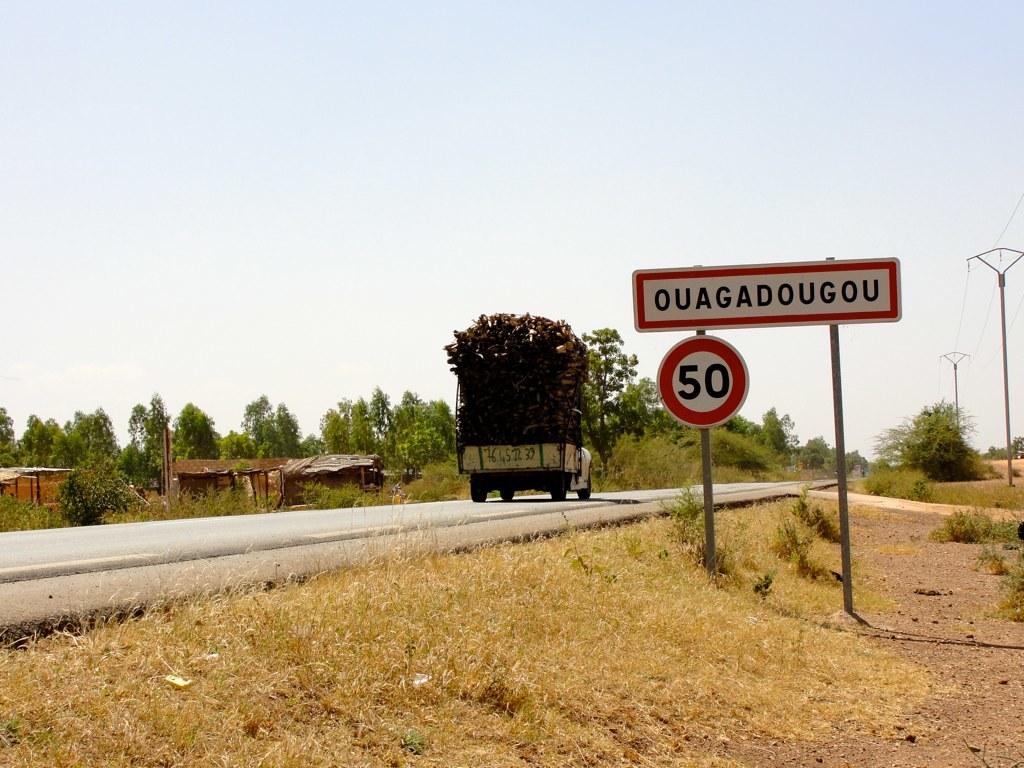Where is the car going?
Your answer should be very brief. Ouagadougou. What does the number say on the sign?
Give a very brief answer. 50. 